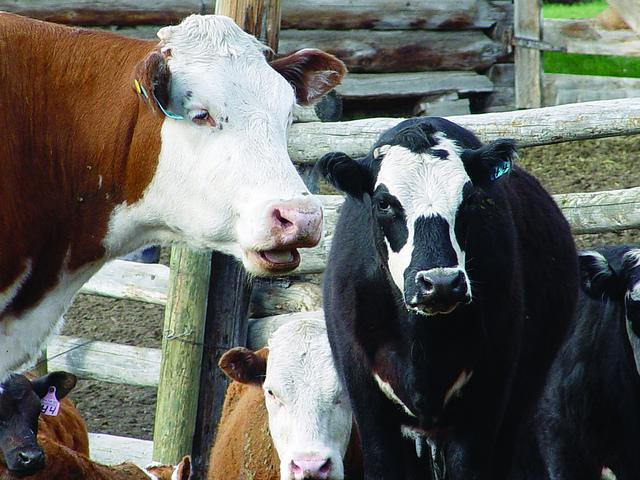Who put the tag on the cows ear?

Choices:
A) another cow
B) dog
C) human
D) alien human 